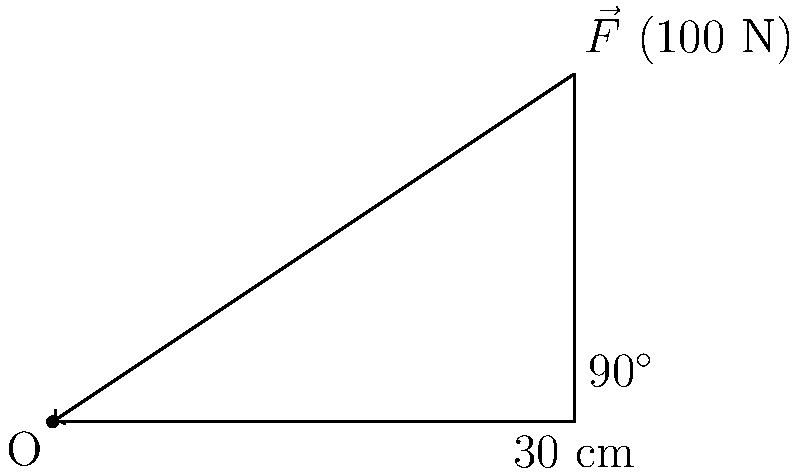You're tightening a bolt on an engine block using a wrench. The wrench is 30 cm long, and you're applying a force of 100 N perpendicular to the wrench. What is the magnitude of the torque applied to the bolt? To solve this problem, we'll use the formula for torque:

$$\tau = r \times F \sin\theta$$

Where:
- $\tau$ is the torque
- $r$ is the length of the lever arm (wrench)
- $F$ is the applied force
- $\theta$ is the angle between the force vector and the lever arm

Step 1: Identify the given values
- $r = 30$ cm $= 0.3$ m
- $F = 100$ N
- $\theta = 90^\circ$ (force is perpendicular to the wrench)

Step 2: Simplify the equation
Since $\sin 90^\circ = 1$, our equation becomes:
$$\tau = r \times F$$

Step 3: Calculate the torque
$$\tau = 0.3 \text{ m} \times 100 \text{ N} = 30 \text{ N}\cdot\text{m}$$

Therefore, the magnitude of the torque applied to the bolt is 30 N⋅m.
Answer: 30 N⋅m 